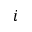<formula> <loc_0><loc_0><loc_500><loc_500>i</formula> 